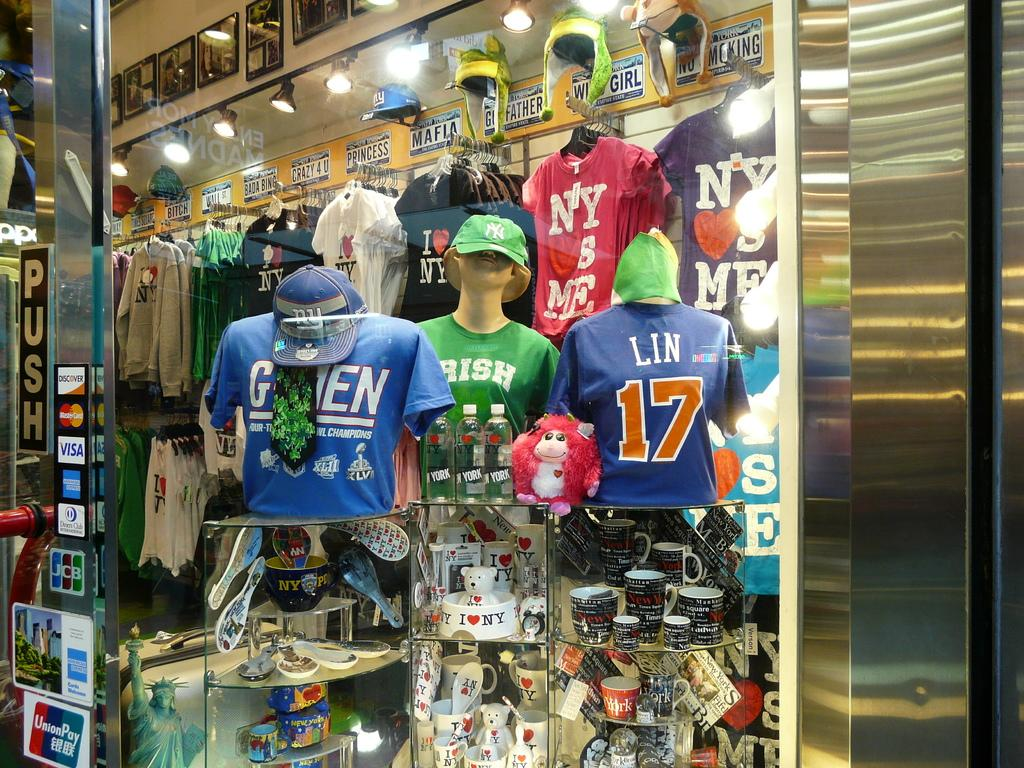<image>
Provide a brief description of the given image. A display of t-shirts include a couple with a NY LOVES ME slogan. 